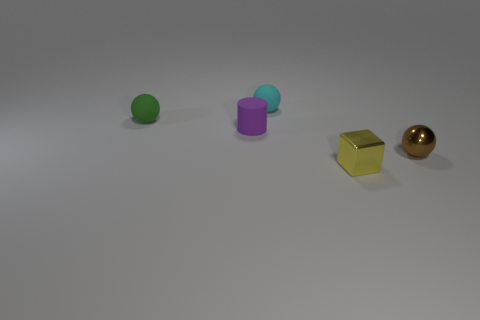Can you describe the objects and their colors in the image? There are four objects in the image. Starting from the left, there is a green sphere, a purple cylinder, a yellow cube, and a gold sphere.  What can you infer about the lighting in the scene? The lighting in the scene appears to be diffused, with the shadows suggesting a light source coming from above and possible ambient light contributing to the softness of the shadows. 